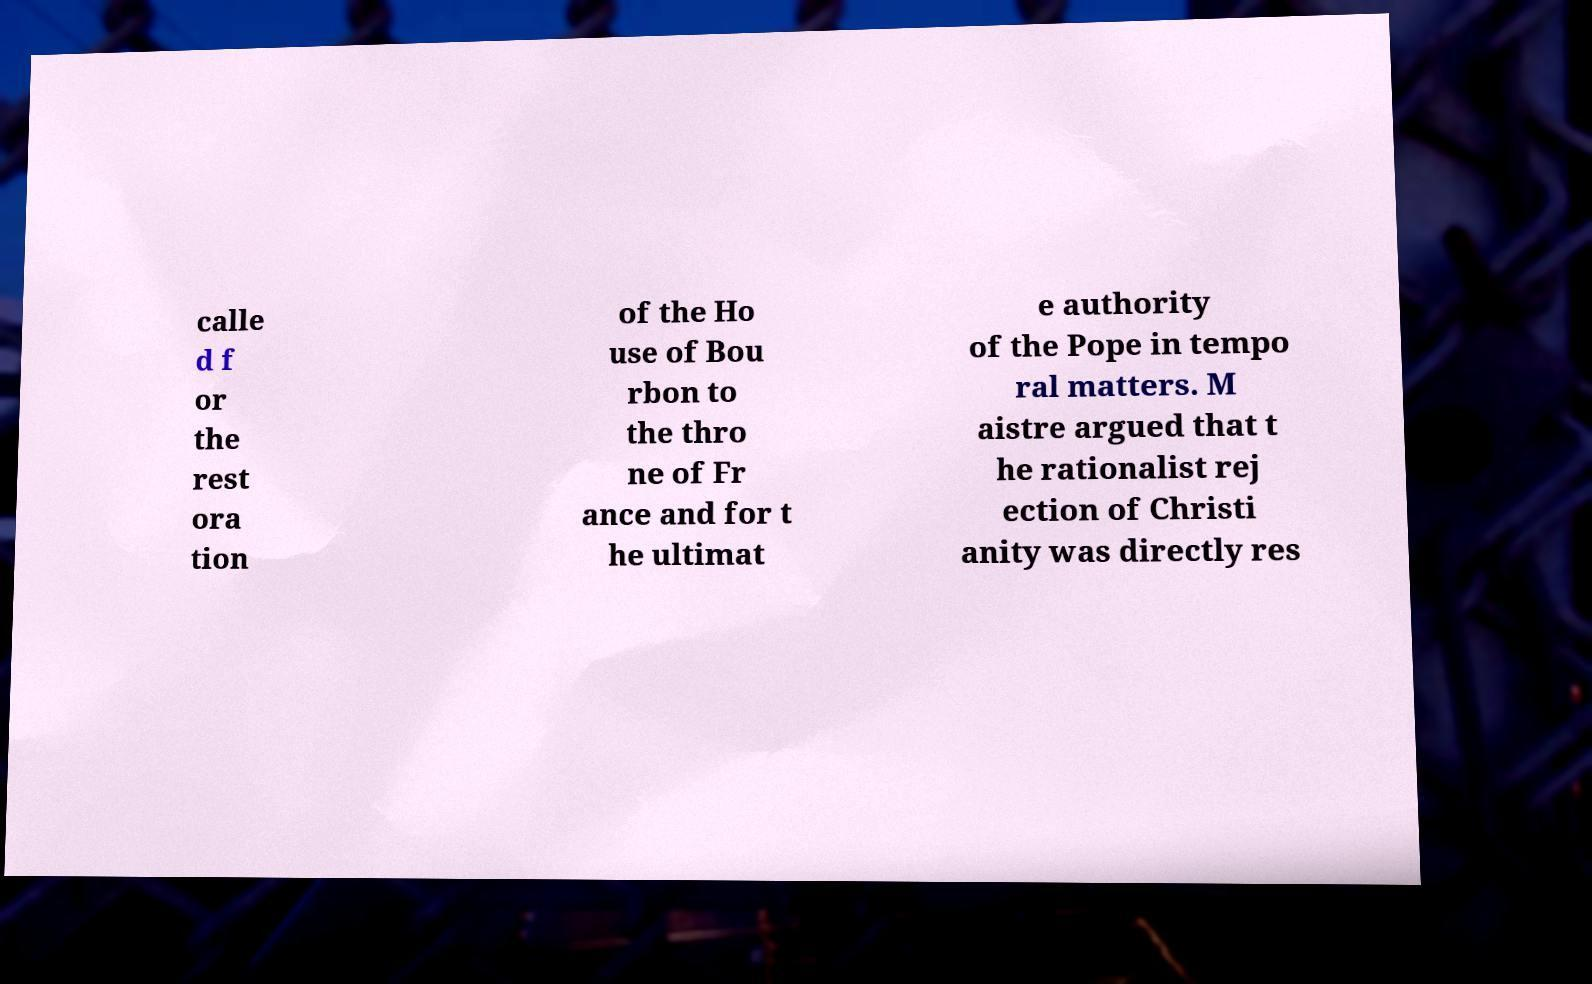There's text embedded in this image that I need extracted. Can you transcribe it verbatim? calle d f or the rest ora tion of the Ho use of Bou rbon to the thro ne of Fr ance and for t he ultimat e authority of the Pope in tempo ral matters. M aistre argued that t he rationalist rej ection of Christi anity was directly res 